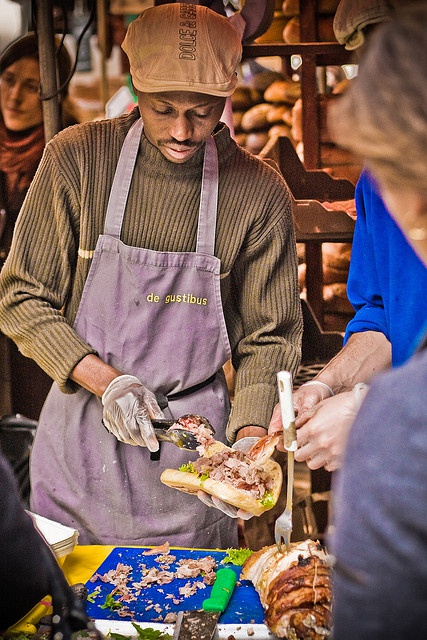Describe the objects in this image and their specific colors. I can see people in lightgray, darkgray, gray, and black tones, people in lightgray, gray, and black tones, people in lightgray, tan, and blue tones, people in lightgray, black, maroon, and brown tones, and people in lightgray, black, and gray tones in this image. 